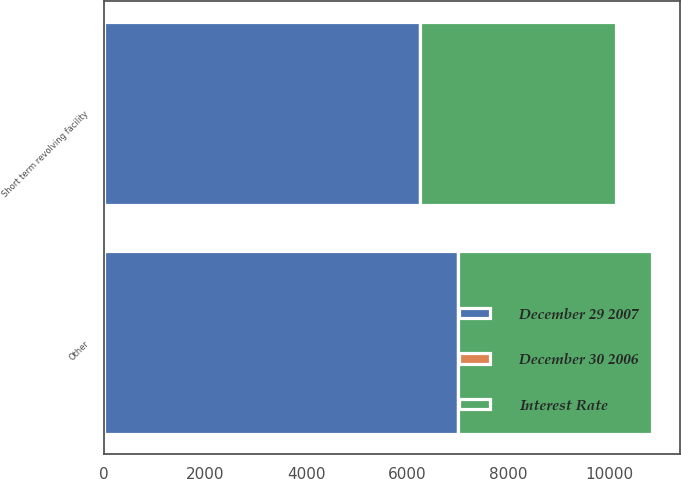Convert chart to OTSL. <chart><loc_0><loc_0><loc_500><loc_500><stacked_bar_chart><ecel><fcel>Short term revolving facility<fcel>Other<nl><fcel>December 30 2006<fcel>10.5<fcel>6.7<nl><fcel>December 29 2007<fcel>6245<fcel>6998<nl><fcel>Interest Rate<fcel>3877<fcel>3833<nl></chart> 